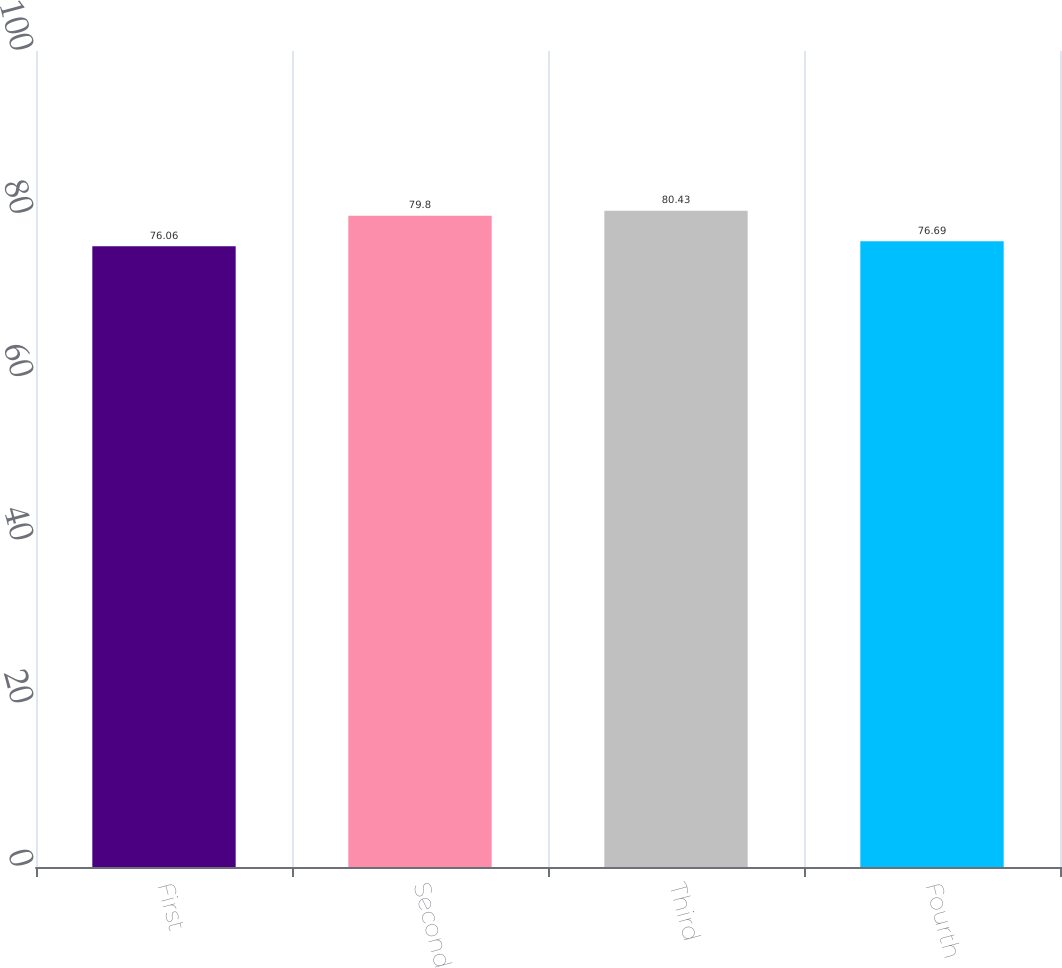Convert chart to OTSL. <chart><loc_0><loc_0><loc_500><loc_500><bar_chart><fcel>First<fcel>Second<fcel>Third<fcel>Fourth<nl><fcel>76.06<fcel>79.8<fcel>80.43<fcel>76.69<nl></chart> 